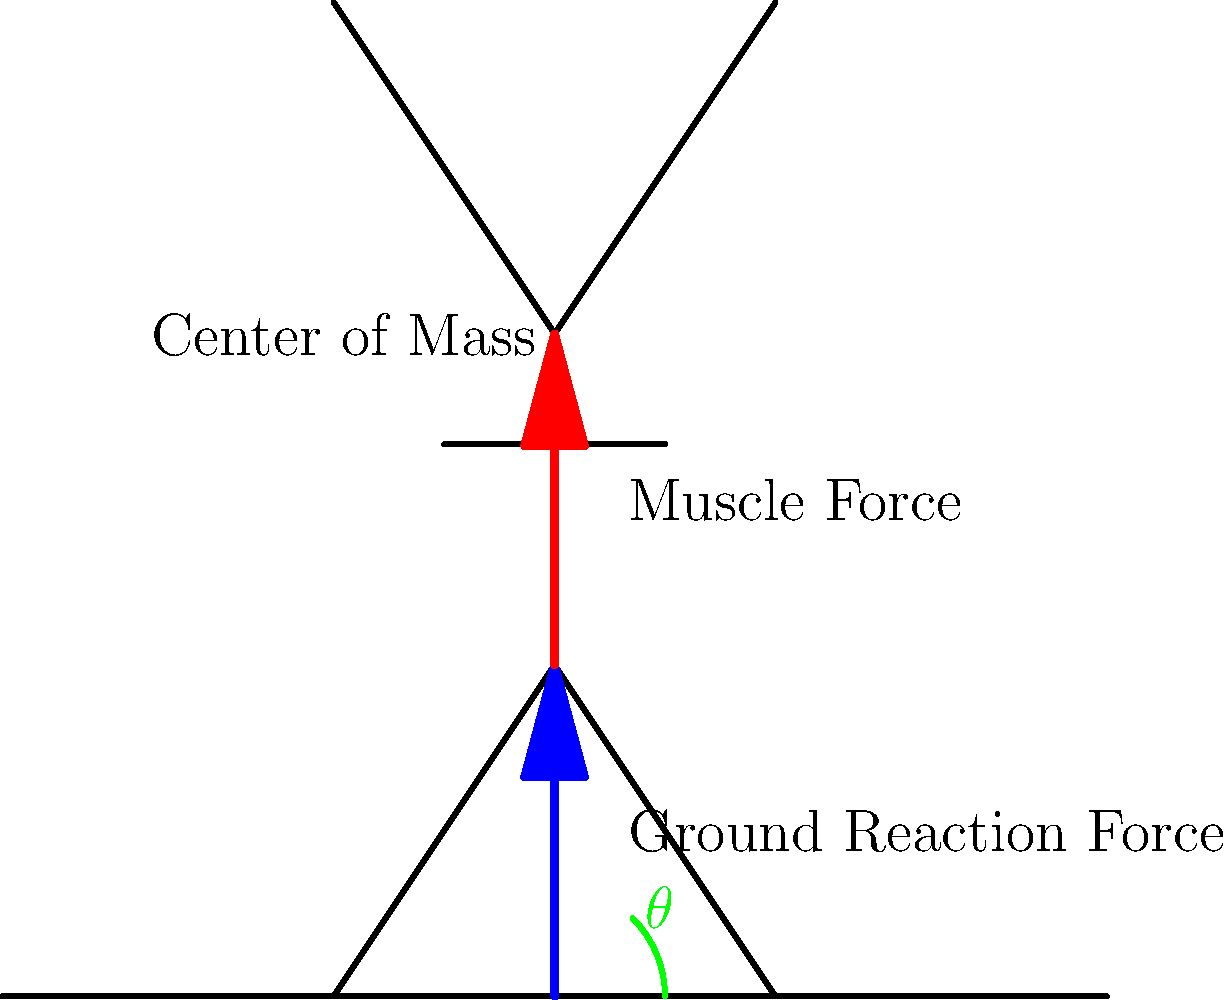As a safety-aware high school basketball coach, you're analyzing the biomechanics of jumping to improve your players' performance and reduce injury risk. Consider the stick figure diagram above, which illustrates a player at the initial phase of a vertical jump. If the player's mass is 75 kg and they achieve a vertical velocity of 3 m/s at takeoff, calculate the average power output during the propulsive phase of the jump, assuming the center of mass rises by 0.4 m during this phase. To calculate the average power output during the propulsive phase of the jump, we'll follow these steps:

1. Identify the relevant physical quantities:
   - Mass (m) = 75 kg
   - Final vertical velocity (v) = 3 m/s
   - Change in height of center of mass (h) = 0.4 m

2. Calculate the change in kinetic energy (ΔKE):
   $$\Delta KE = \frac{1}{2}mv^2 - \frac{1}{2}mv_0^2 = \frac{1}{2}(75)(3^2) - 0 = 337.5 \text{ J}$$

3. Calculate the change in potential energy (ΔPE):
   $$\Delta PE = mgh = (75)(9.81)(0.4) = 294.3 \text{ J}$$

4. Calculate the total work done (W):
   $$W = \Delta KE + \Delta PE = 337.5 + 294.3 = 631.8 \text{ J}$$

5. Estimate the time of the propulsive phase (t):
   Using the equation of motion: $h = \frac{1}{2}at^2$
   $$0.4 = \frac{1}{2}(\frac{3}{t})t^2$$
   $$t = \frac{2(0.4)}{3} = 0.267 \text{ s}$$

6. Calculate the average power output (P):
   $$P = \frac{W}{t} = \frac{631.8}{0.267} = 2366 \text{ W}$$

Therefore, the average power output during the propulsive phase of the jump is approximately 2366 W or 2.37 kW.
Answer: 2.37 kW 